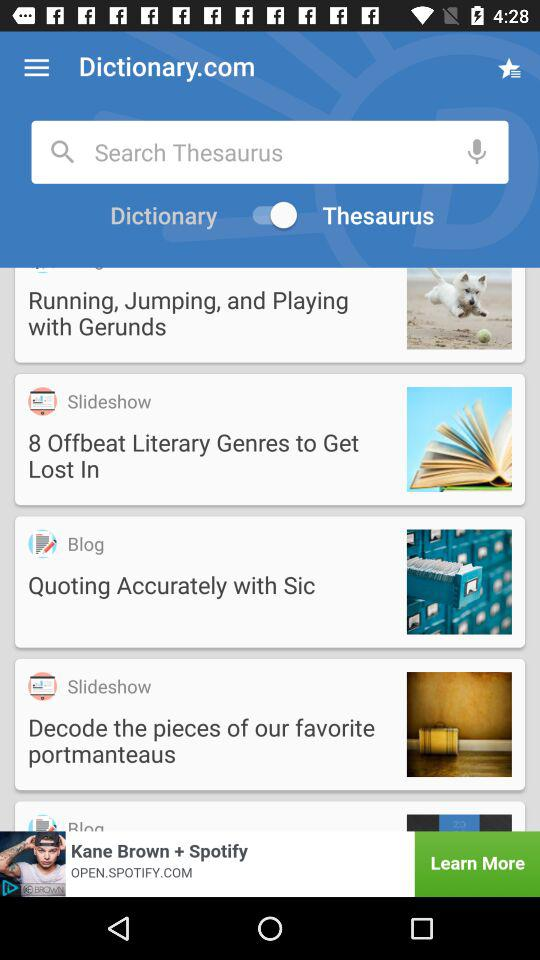Out of Dictionaries and Thesaurus, which option is selected? The selected option is "Thesaurus". 